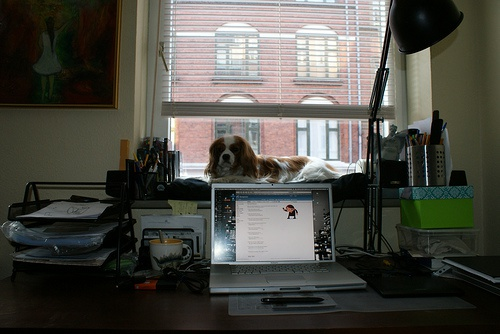Describe the objects in this image and their specific colors. I can see laptop in black, darkgray, gray, and purple tones, dog in black, gray, darkgray, and lightgray tones, cup in black, gray, and maroon tones, cell phone in black, purple, and gray tones, and book in black, purple, and blue tones in this image. 